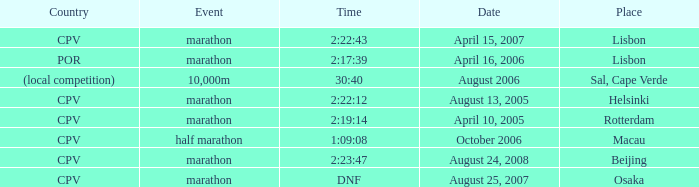Would you be able to parse every entry in this table? {'header': ['Country', 'Event', 'Time', 'Date', 'Place'], 'rows': [['CPV', 'marathon', '2:22:43', 'April 15, 2007', 'Lisbon'], ['POR', 'marathon', '2:17:39', 'April 16, 2006', 'Lisbon'], ['(local competition)', '10,000m', '30:40', 'August 2006', 'Sal, Cape Verde'], ['CPV', 'marathon', '2:22:12', 'August 13, 2005', 'Helsinki'], ['CPV', 'marathon', '2:19:14', 'April 10, 2005', 'Rotterdam'], ['CPV', 'half marathon', '1:09:08', 'October 2006', 'Macau'], ['CPV', 'marathon', '2:23:47', 'August 24, 2008', 'Beijing'], ['CPV', 'marathon', 'DNF', 'August 25, 2007', 'Osaka']]} What is the Country of the 10,000m Event? (local competition). 